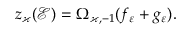Convert formula to latex. <formula><loc_0><loc_0><loc_500><loc_500>z _ { \varkappa } ( \mathcal { E } ) = \Omega _ { \varkappa , - 1 } ( f _ { \varepsilon } + g _ { \varepsilon } ) .</formula> 